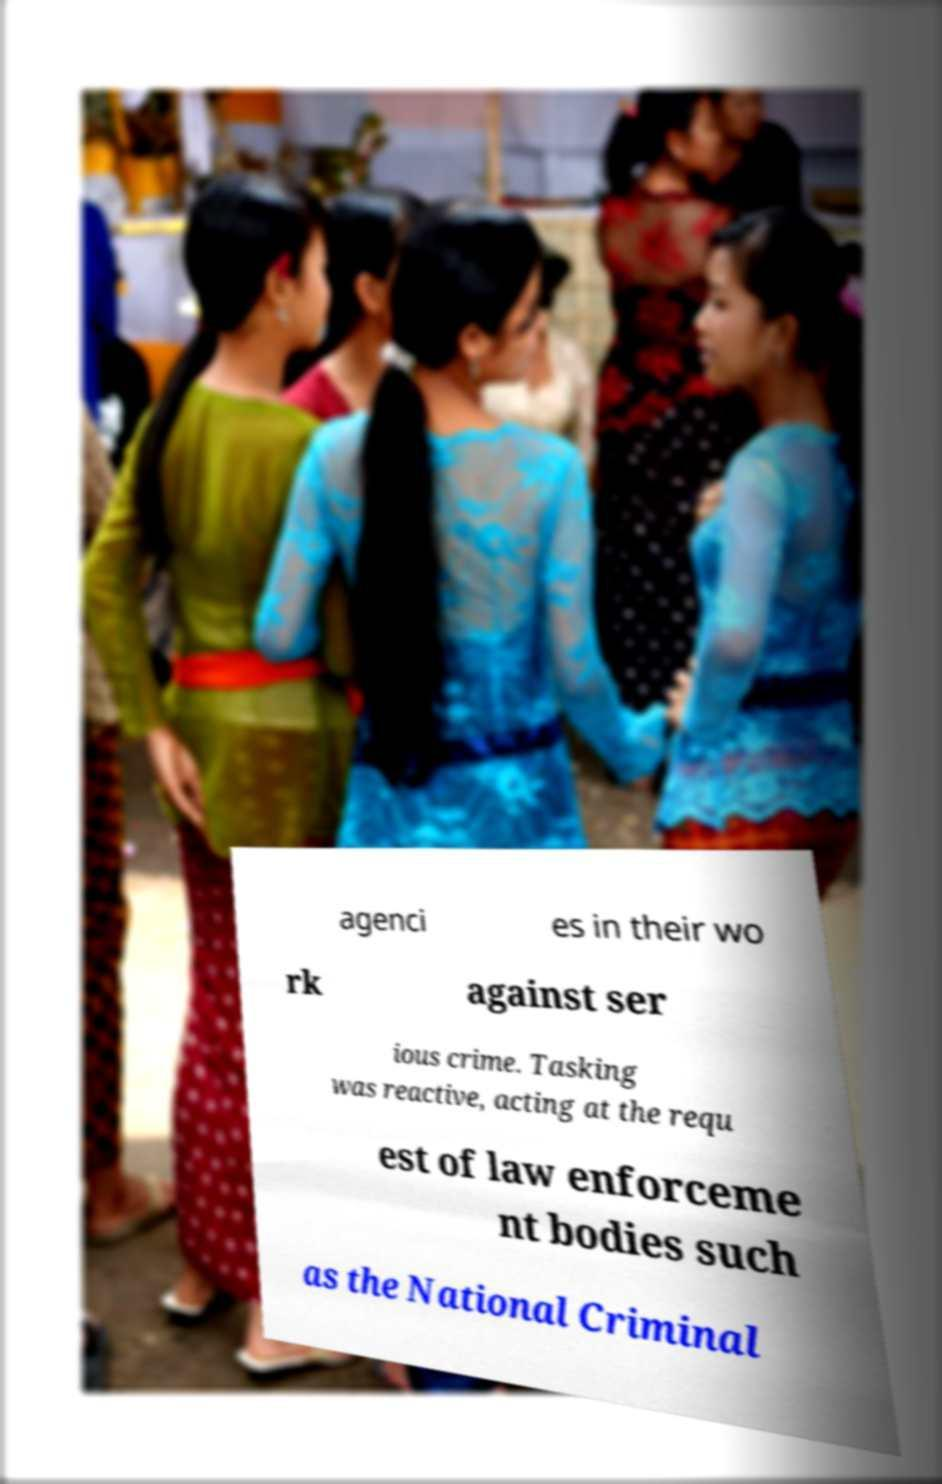Can you accurately transcribe the text from the provided image for me? agenci es in their wo rk against ser ious crime. Tasking was reactive, acting at the requ est of law enforceme nt bodies such as the National Criminal 